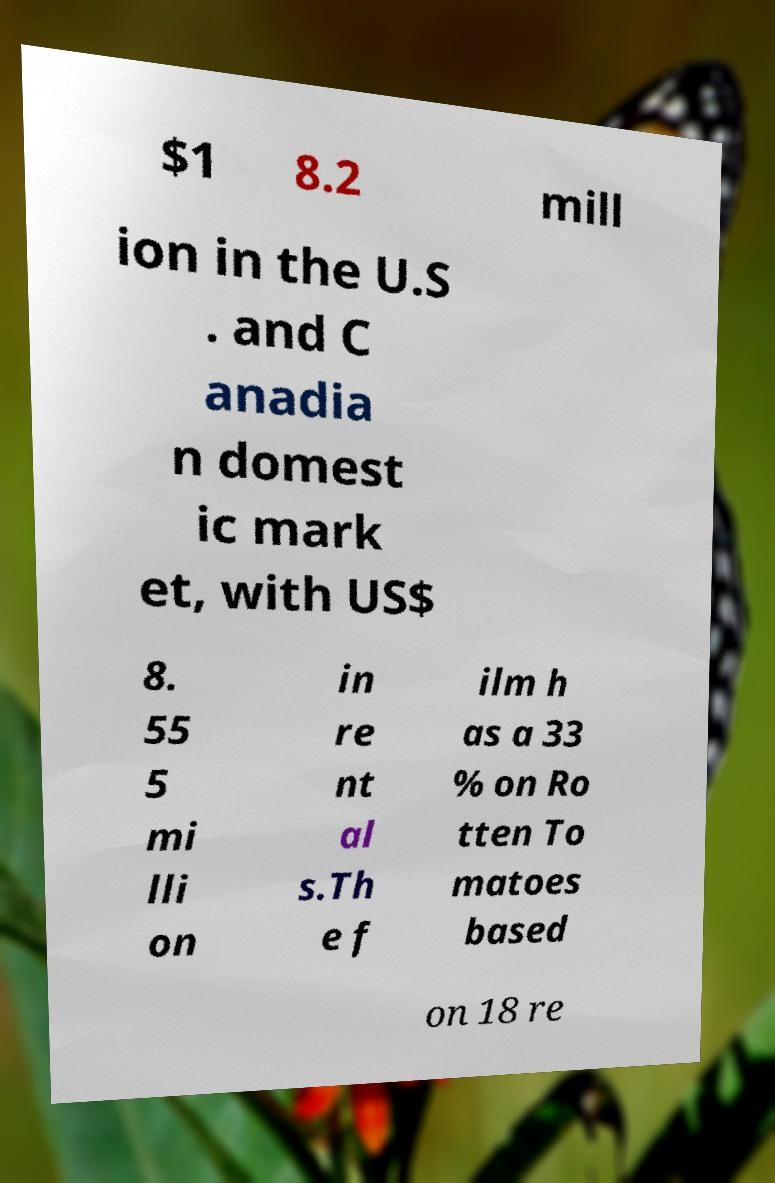There's text embedded in this image that I need extracted. Can you transcribe it verbatim? $1 8.2 mill ion in the U.S . and C anadia n domest ic mark et, with US$ 8. 55 5 mi lli on in re nt al s.Th e f ilm h as a 33 % on Ro tten To matoes based on 18 re 